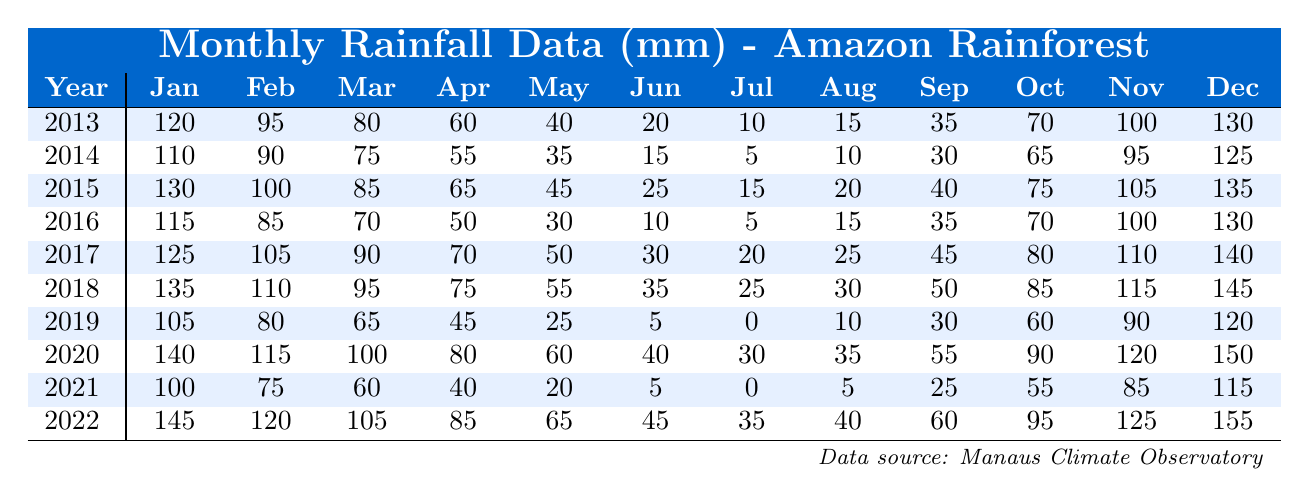What was the total rainfall in May 2022? To find the total rainfall in May 2022, refer to the table and locate the value for May in the row for 2022. The value is 65 mm.
Answer: 65 mm Which year had the highest rainfall in July? To determine the year with the highest rainfall in July, check the July values across all years. The highest value appears in 2020, which is 30 mm.
Answer: 2020 What was the average rainfall for the month of October over the past decade? Add the October rainfall values for each year: 70 + 65 + 75 + 70 + 80 + 85 + 90 + 90 + 55 + 95 =  855 mm. Divide by 10 for the average: 855/10 = 85.5 mm.
Answer: 85.5 mm Was there a year in which every month received more than 100 mm of rainfall? Check each year's monthly rainfall to see if every month exceeds 100 mm. No year has all values above 100 mm, so the answer is no.
Answer: No What is the difference in total rainfall between the years 2014 and 2019? First, sum the rainfall for 2014: 110 + 90 + 75 + 55 + 35 + 15 + 5 + 10 + 30 + 65 + 95 + 125 =  730 mm. Now sum for 2019: 105 + 80 + 65 + 45 + 25 + 5 + 0 + 10 + 30 + 60 + 90 + 120 =  630 mm. The difference is 730 - 630 = 100 mm.
Answer: 100 mm What was the rainfall pattern in March for the years 2015 to 2021? Looking at the values in March from 2015 to 2021, the values are: 85 mm, 70 mm, 90 mm, 95 mm, 60 mm. The pattern shows fluctuations with no consistent increase or decrease overall.
Answer: Fluctuating values Which month had the highest recorded rainfall in 2018? Check the monthly values for 2018: January (135), February (110), March (95), etc. The highest value in this row is in January at 135 mm.
Answer: January If we look at the average rainfall for the months between May and August from 2013 to 2022, what do we see? First, calculate the average for May (40 mm), June (20 mm), July (10 mm), August (15 mm) from the data. May (40) + June (20) + July (10) + August (15) = 85 mm. Now divide by 4, leading to an average of 21.25 mm.
Answer: 21.25 mm In which year did the rainfall in November exceed 120 mm? Examine the November column for each year. The years 2016, 2017, 2018, 2020, and 2022 all exceeded 120 mm in November.
Answer: 2016, 2017, 2018, 2020, 2022 Which year experienced the lowest total annual rainfall overall? Calculate the total rainfall for each year, then compare those totals. The lowest total is for 2019, which added up to 630 mm across its months.
Answer: 2019 Was there an increase in rainfall observed from 2017 to 2018 for December? Check the December values for both years: 140 mm in 2017 and 145 mm in 2018. There is an increase of 5 mm from 2017 to 2018.
Answer: Yes 